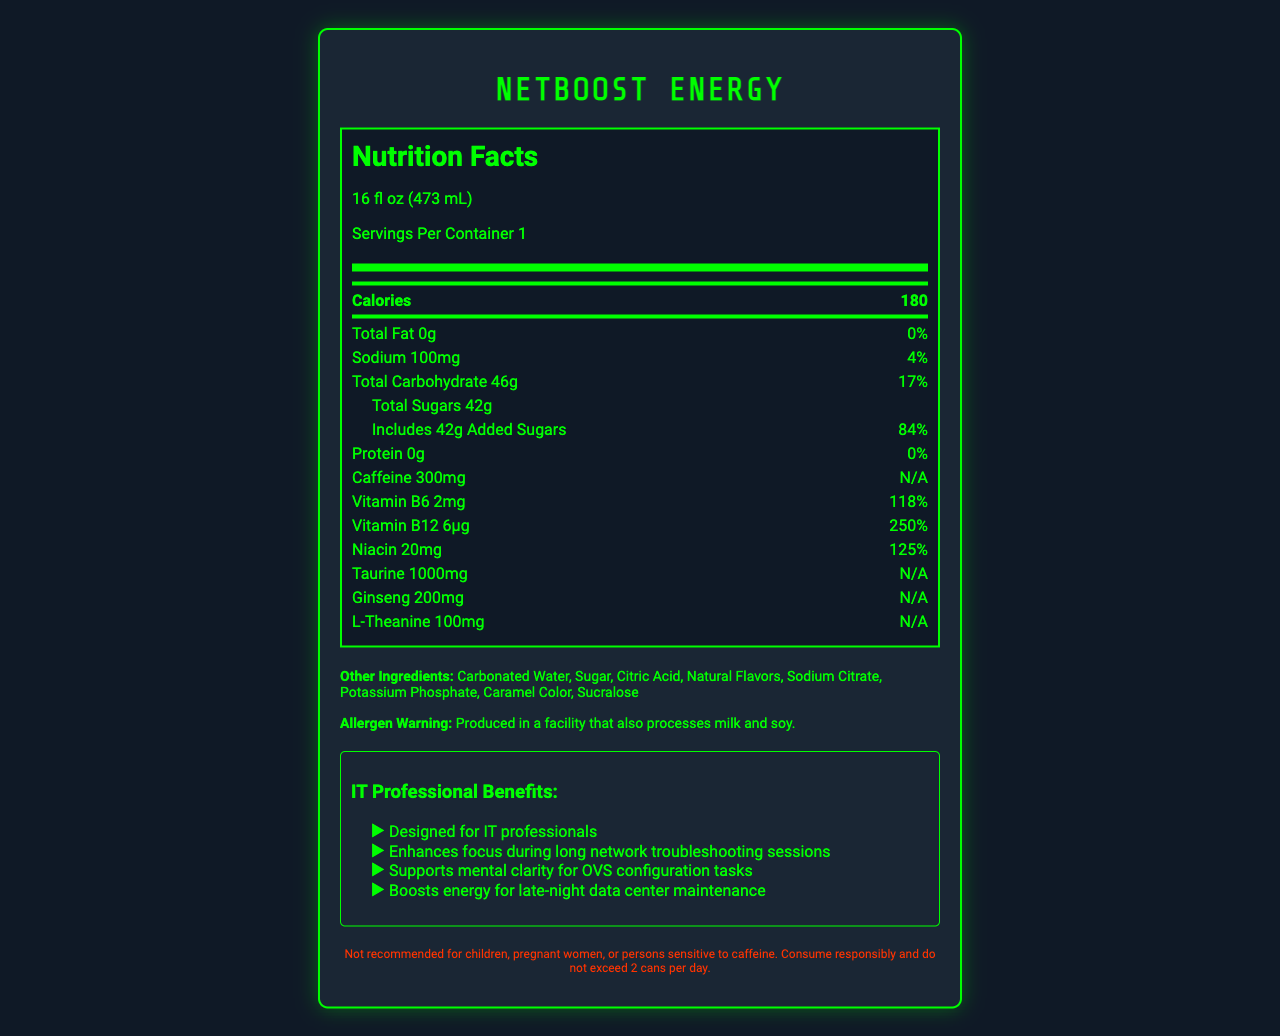how many calories are in a serving of NetBoost Energy? The Nutrition Facts section lists 180 calories per serving.
Answer: 180 calories what is the serving size for NetBoost Energy? The Nutrition Facts section indicates that the serving size is 16 fl oz (473 mL).
Answer: 16 fl oz (473 mL) how much sugar is in one serving of NetBoost Energy? The Nutrition Facts section shows that one serving contains 42g of sugar.
Answer: 42g how much caffeine does NetBoost Energy contain per serving? The Nutrition Facts section lists that the caffeine content is 300mg per serving.
Answer: 300mg what percentage of the daily value of Vitamin B6 does NetBoost Energy provide? The Nutrition Facts section indicates that one serving provides 118% of the daily value of Vitamin B6.
Answer: 118% NetBoost Energy contains how much sodium? The Nutrition Facts section states that there is 100mg of sodium per serving.
Answer: 100mg what allergens are processed in the same facility as NetBoost Energy? The allergen warning section states that the product is produced in a facility that also processes milk and soy.
Answer: Milk and soy which of the following ingredients is not in NetBoost Energy? A. Sugar B. Citric Acid C. Aspartame D. Sucralose The ingredients list includes Sugar, Citric Acid, and Sucralose, but not Aspartame.
Answer: C. Aspartame what benefit is specifically mentioned as supporting mental clarity? A. Enhances focus during long network troubleshooting sessions B. Supports mental clarity for OVS configuration tasks C. Boosts energy for late-night data center maintenance D. Designed for IT professionals The marketing claims section states that NetBoost Energy supports mental clarity for OVS configuration tasks.
Answer: B. Supports mental clarity for OVS configuration tasks is NetBoost Energy recommended for children? The legal disclaimer section states that NetBoost Energy is not recommended for children.
Answer: No summarize the main idea of the NetBoost Energy document. The document provides detailed nutrition facts and marketing claims targeted towards IT professionals, listing the ingredients and health warnings.
Answer: NetBoost Energy is a caffeine-rich energy drink designed for IT professionals, offering benefits such as enhanced focus and mental clarity for OVS configuration tasks and boosted energy for late-night maintenance. The drink contains various ingredients, including caffeine, vitamins, and amino acids, and comes with specific allergen warnings and consumption recommendations. can we find the exact time of manufacture for NetBoost Energy in this document? The document does not provide information regarding the exact time of manufacture for NetBoost Energy.
Answer: Cannot be determined 